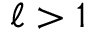Convert formula to latex. <formula><loc_0><loc_0><loc_500><loc_500>\ell > 1</formula> 